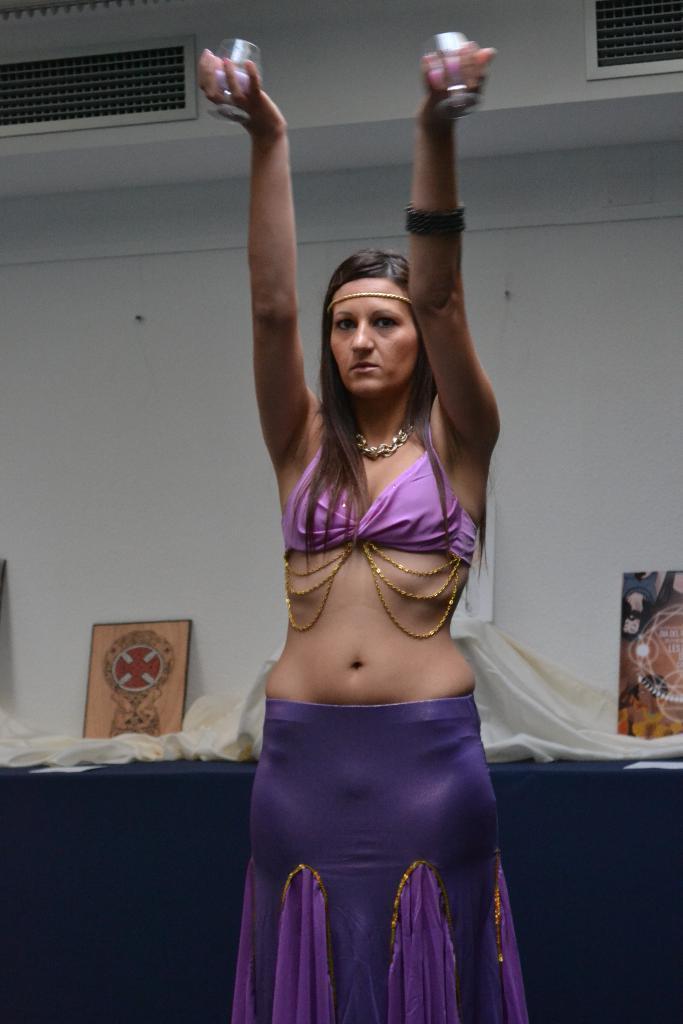Can you describe this image briefly? A beautiful woman is raising her 2 hands, she wore purple color dress. Behind her there is a wall. 